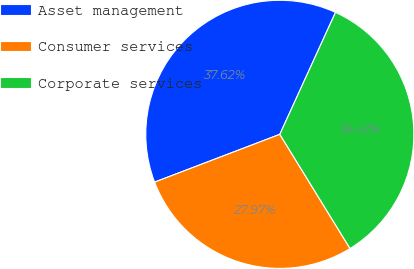Convert chart to OTSL. <chart><loc_0><loc_0><loc_500><loc_500><pie_chart><fcel>Asset management<fcel>Consumer services<fcel>Corporate services<nl><fcel>37.62%<fcel>27.97%<fcel>34.41%<nl></chart> 